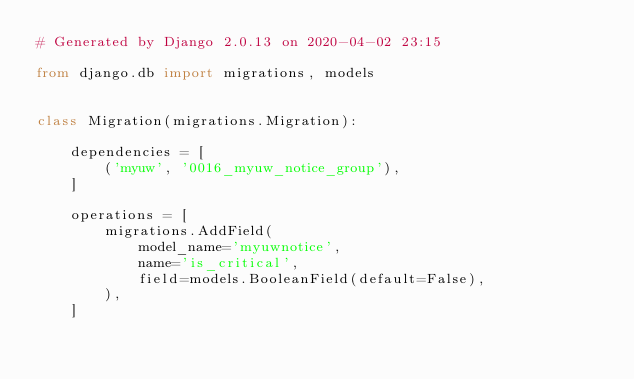Convert code to text. <code><loc_0><loc_0><loc_500><loc_500><_Python_># Generated by Django 2.0.13 on 2020-04-02 23:15

from django.db import migrations, models


class Migration(migrations.Migration):

    dependencies = [
        ('myuw', '0016_myuw_notice_group'),
    ]

    operations = [
        migrations.AddField(
            model_name='myuwnotice',
            name='is_critical',
            field=models.BooleanField(default=False),
        ),
    ]
</code> 